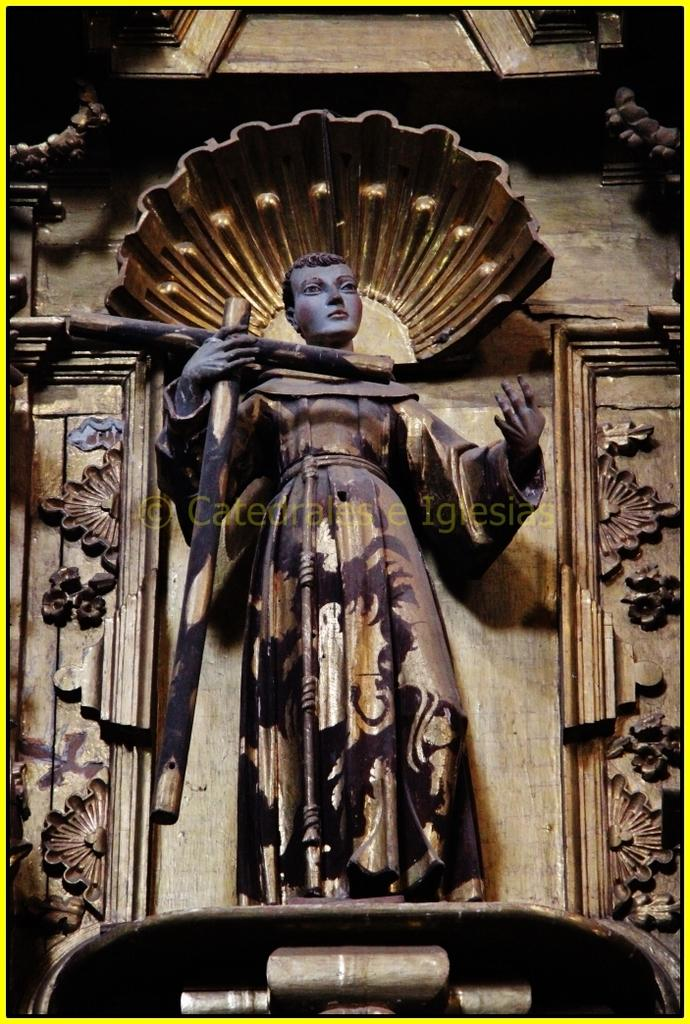What is the main subject in the image? There is a statue in the image. What can be seen in the background of the image? There is a designed wall in the image. What is located in the middle of the image? There is a watermark in the middle of the image. What type of bomb can be seen in the image? There is no bomb present in the image; it features a statue and a designed wall. What type of flesh can be seen on the statue in the image? The statue in the image is not made of flesh, and therefore no such material can be observed. 